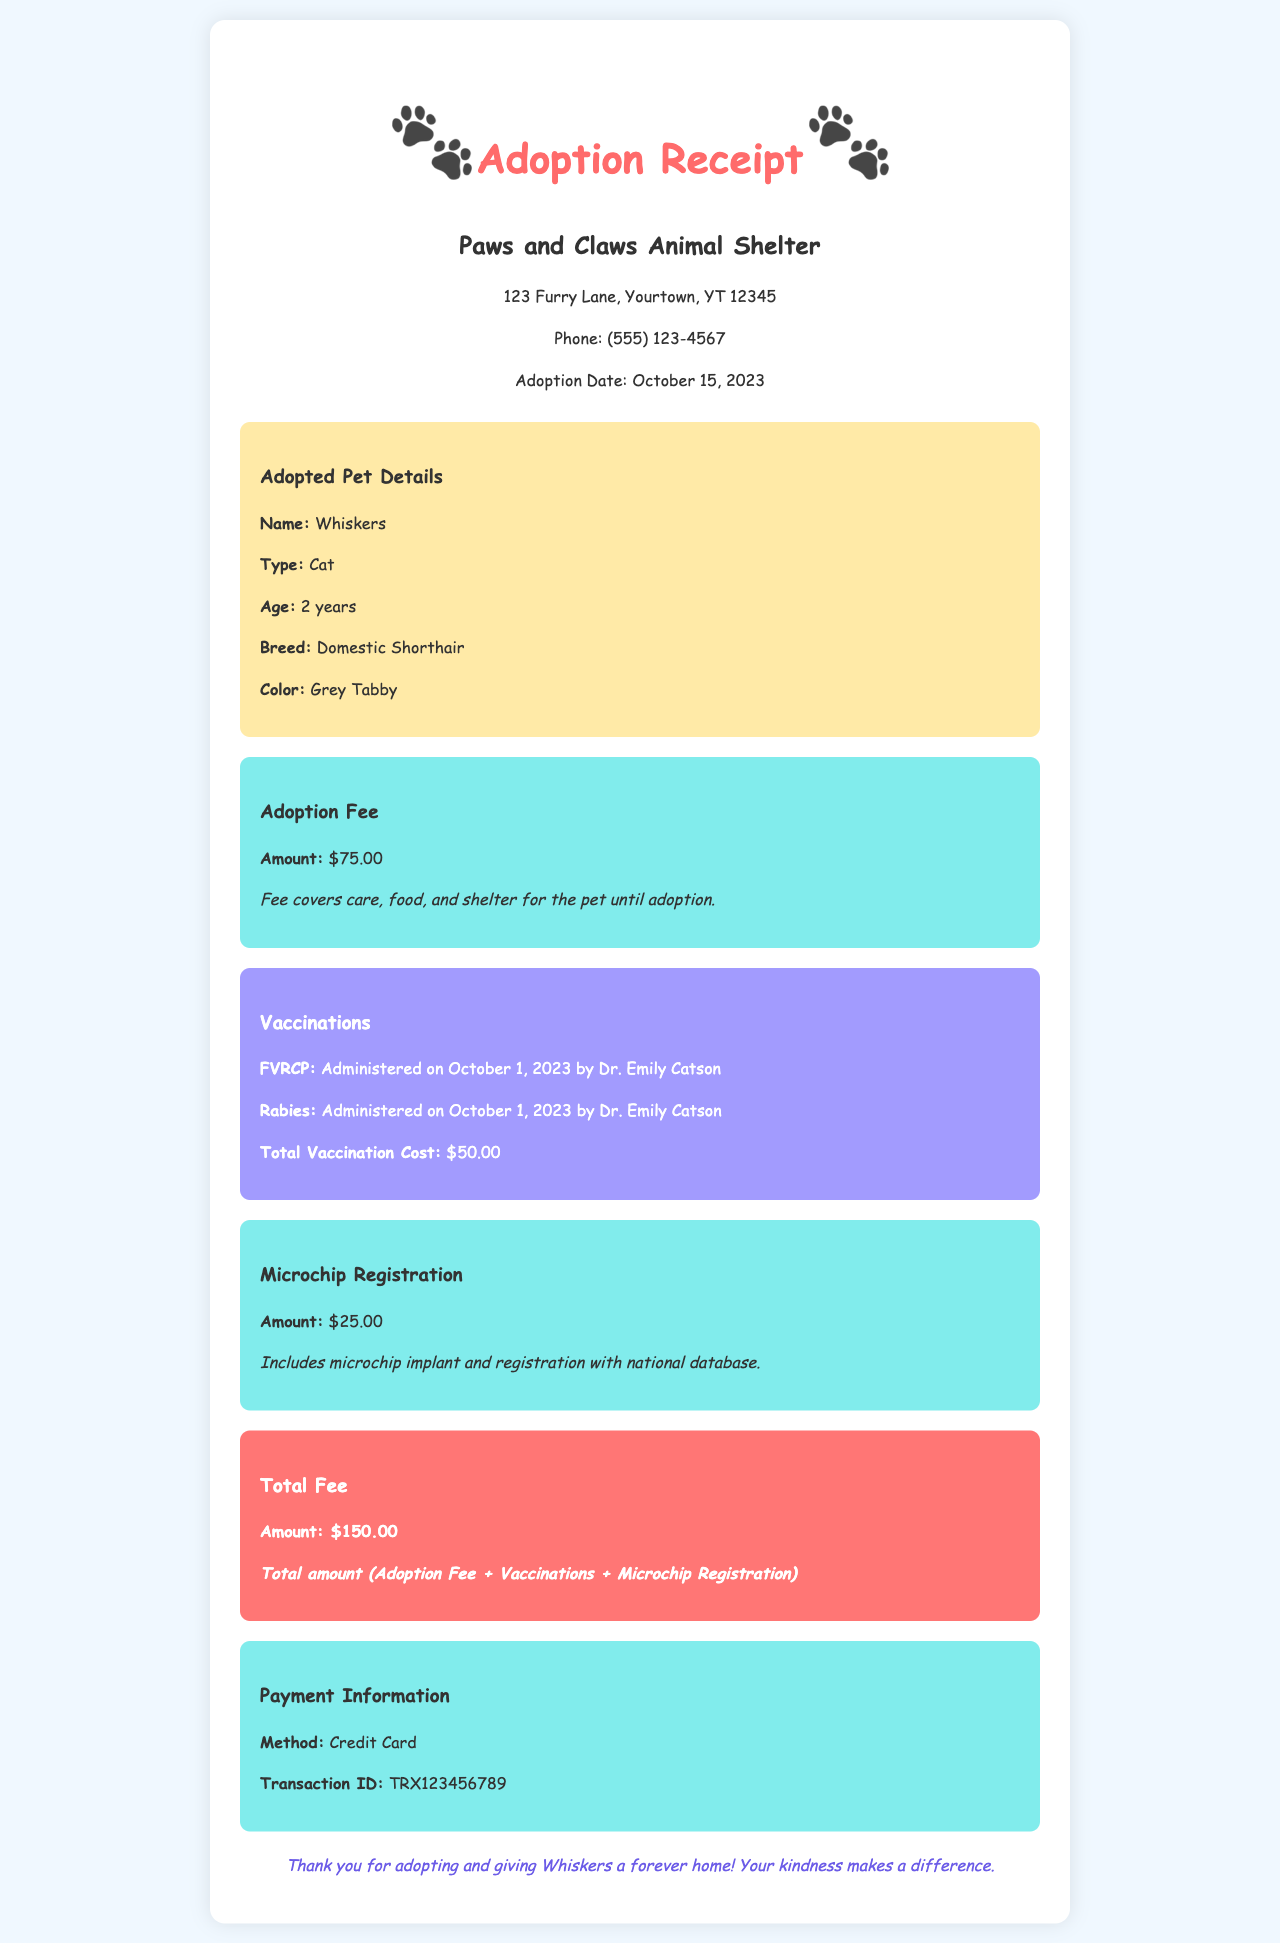What is the adoption fee? The adoption fee is specified in the fee section of the document as $75.00.
Answer: $75.00 When was Whiskers adopted? The adoption date is noted in the shelter info section as October 15, 2023.
Answer: October 15, 2023 Who administered the vaccinations? The veterinarian's name is mentioned in the vaccination section as Dr. Emily Catson.
Answer: Dr. Emily Catson What is the total cost of vaccinations? The total vaccination cost is detailed in the vaccination section as $50.00.
Answer: $50.00 What is included in the microchip registration fee? The microchip registration includes the implant and registration with the national database as stated in the fee section.
Answer: Microchip implant and registration What type of pet was adopted? The adopted pet type is specified in the pet info section as Cat.
Answer: Cat What is the total fee for the adoption, vaccinations, and microchip registration? The total fee is the sum of the adoption fee, vaccination cost, and microchip registration, shown as $150.00 in the total section.
Answer: $150.00 What method of payment was used? The payment method is indicated in the payment information section as Credit Card.
Answer: Credit Card What breed is Whiskers? Whiskers' breed is mentioned in the adopted pet details as Domestic Shorthair.
Answer: Domestic Shorthair 